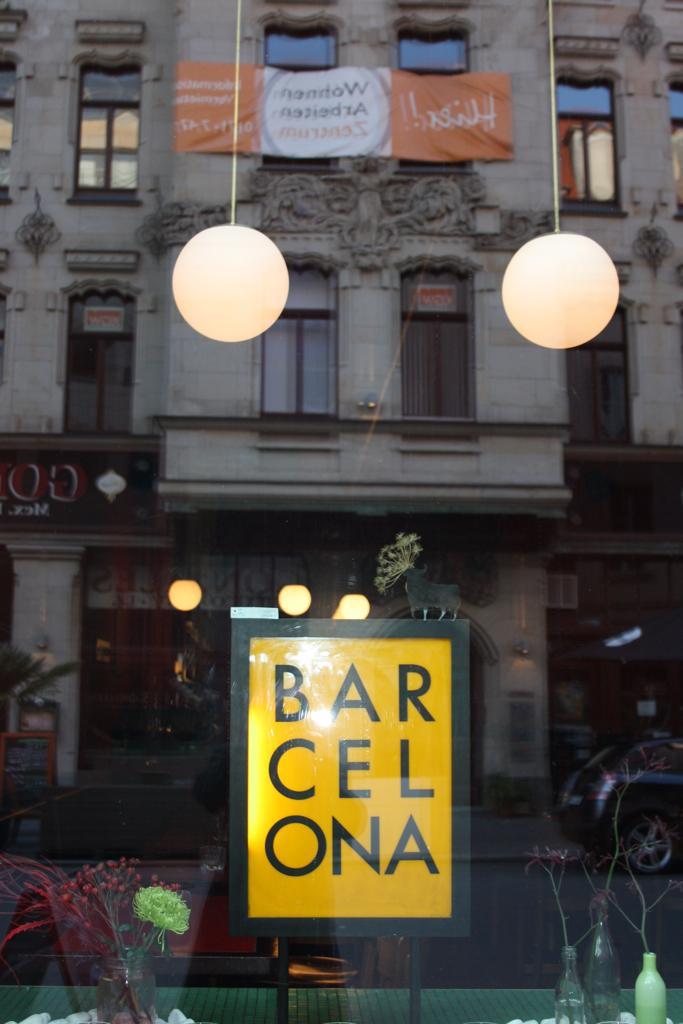Could you give a brief overview of what you see in this image? In this image in the front there is a board with some text written on it. In the background there is a building and there are lights hanging and on the building there are banners with some text written on it. In front of the building on the right side there is a car which is black in colour and in the front there are bottles and there are plants. 